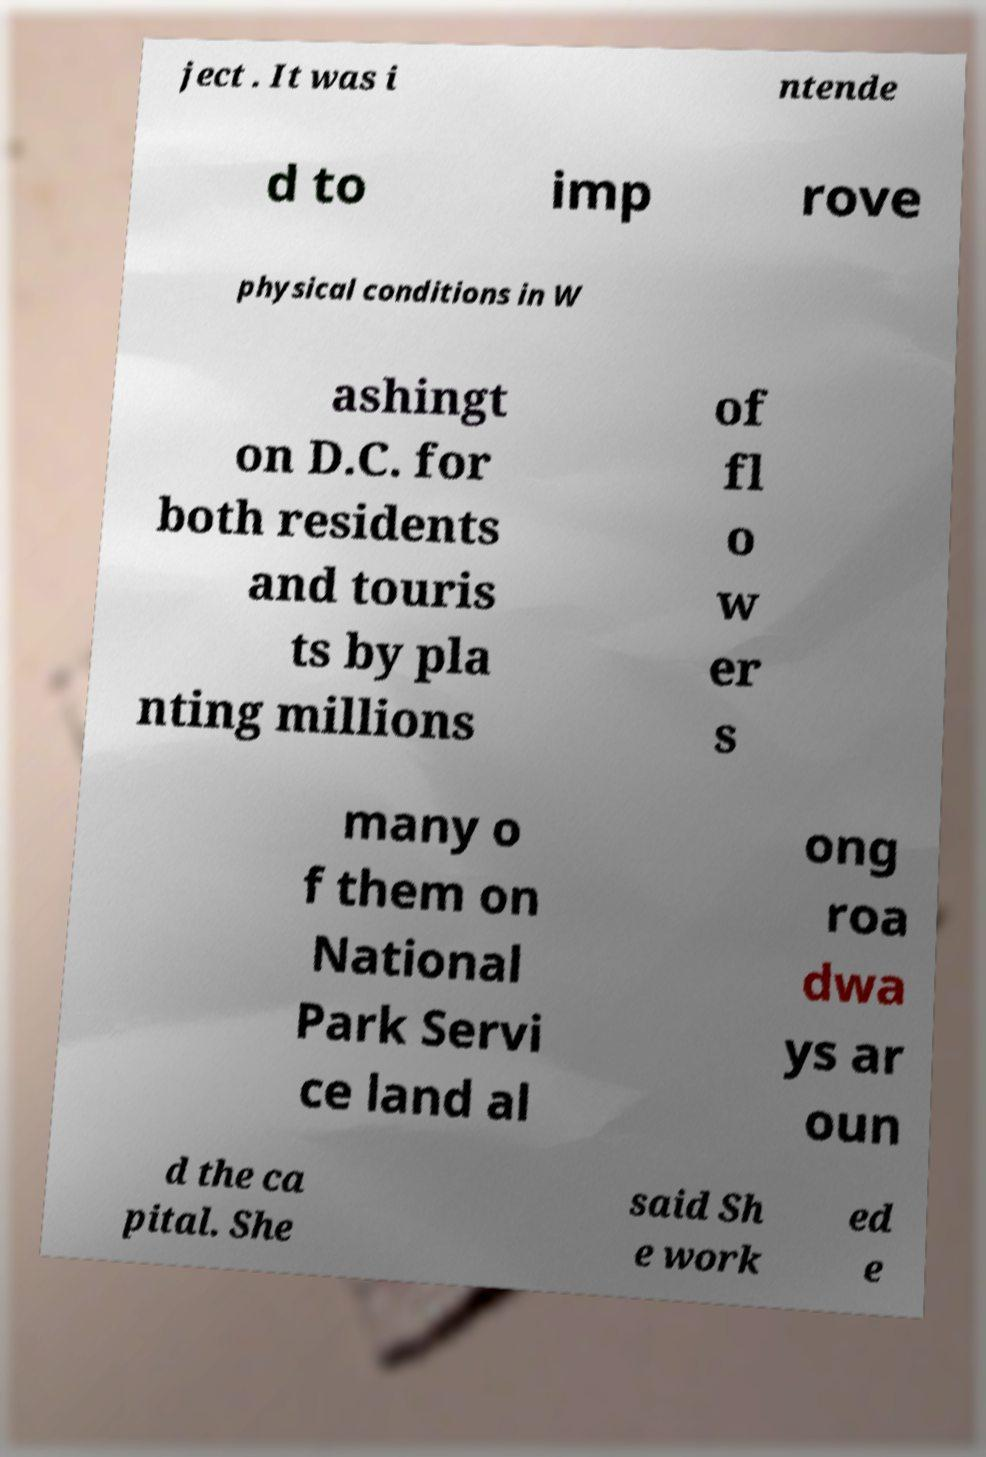There's text embedded in this image that I need extracted. Can you transcribe it verbatim? ject . It was i ntende d to imp rove physical conditions in W ashingt on D.C. for both residents and touris ts by pla nting millions of fl o w er s many o f them on National Park Servi ce land al ong roa dwa ys ar oun d the ca pital. She said Sh e work ed e 